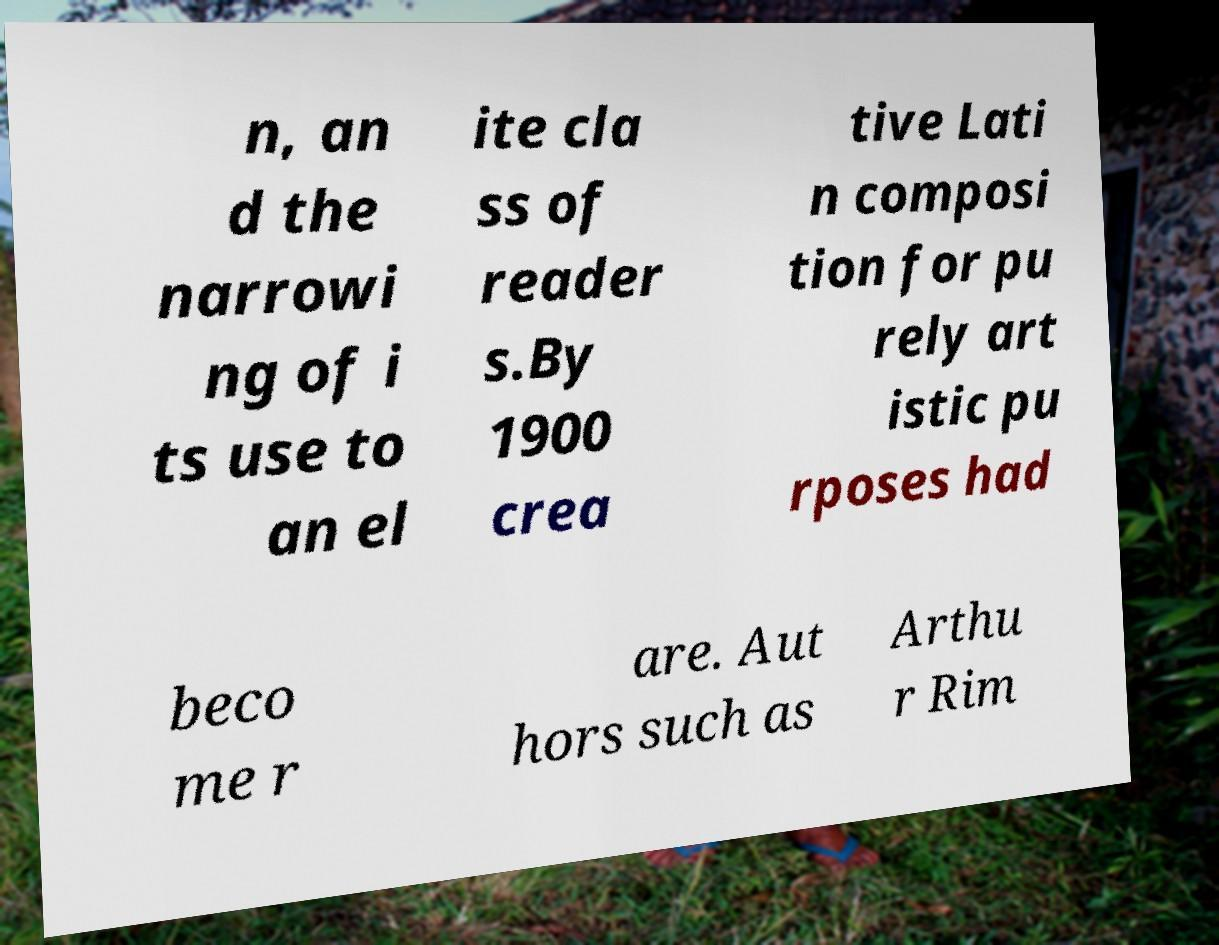Can you accurately transcribe the text from the provided image for me? n, an d the narrowi ng of i ts use to an el ite cla ss of reader s.By 1900 crea tive Lati n composi tion for pu rely art istic pu rposes had beco me r are. Aut hors such as Arthu r Rim 